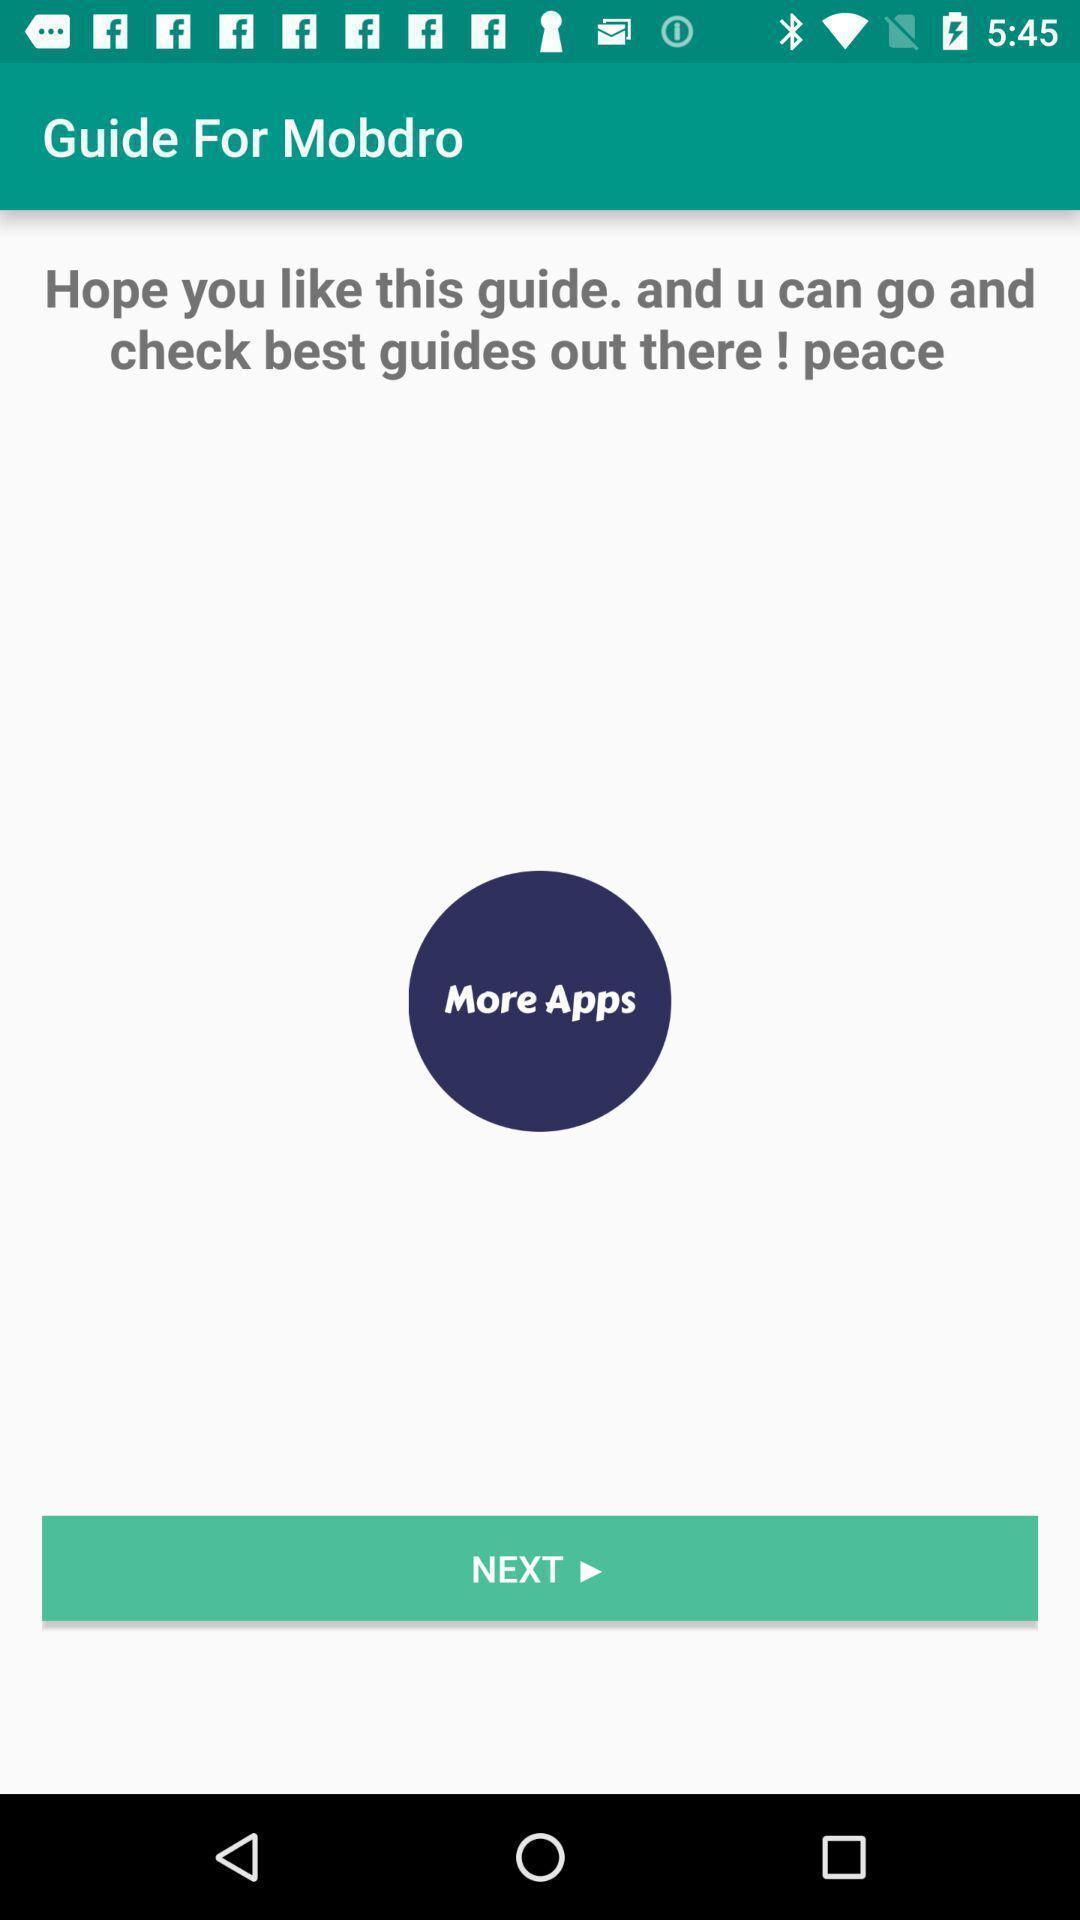Describe this image in words. Screen shows guide for mobdro. 